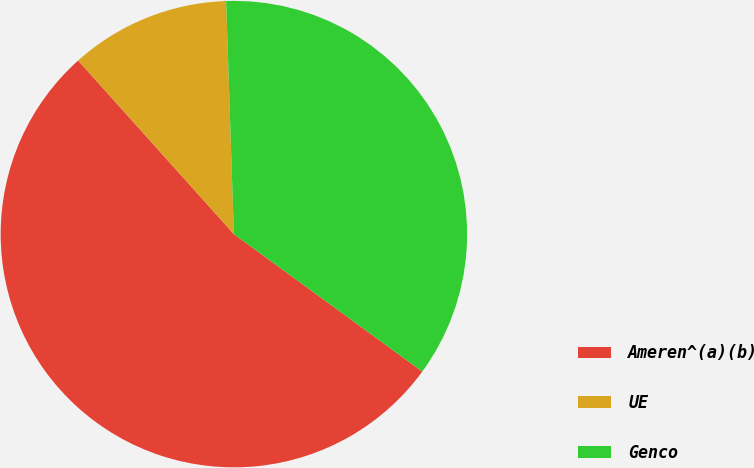Convert chart to OTSL. <chart><loc_0><loc_0><loc_500><loc_500><pie_chart><fcel>Ameren^(a)(b)<fcel>UE<fcel>Genco<nl><fcel>53.33%<fcel>11.11%<fcel>35.56%<nl></chart> 